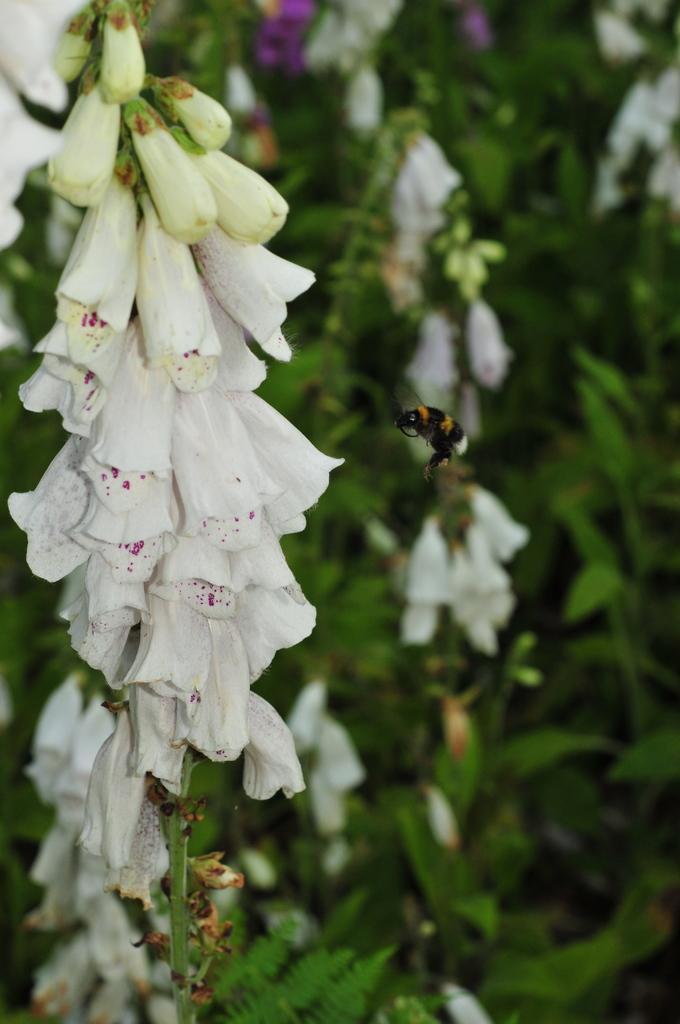Can you describe this image briefly? In this image I can see flowering plants and also a bee. This image is taken in a day. 